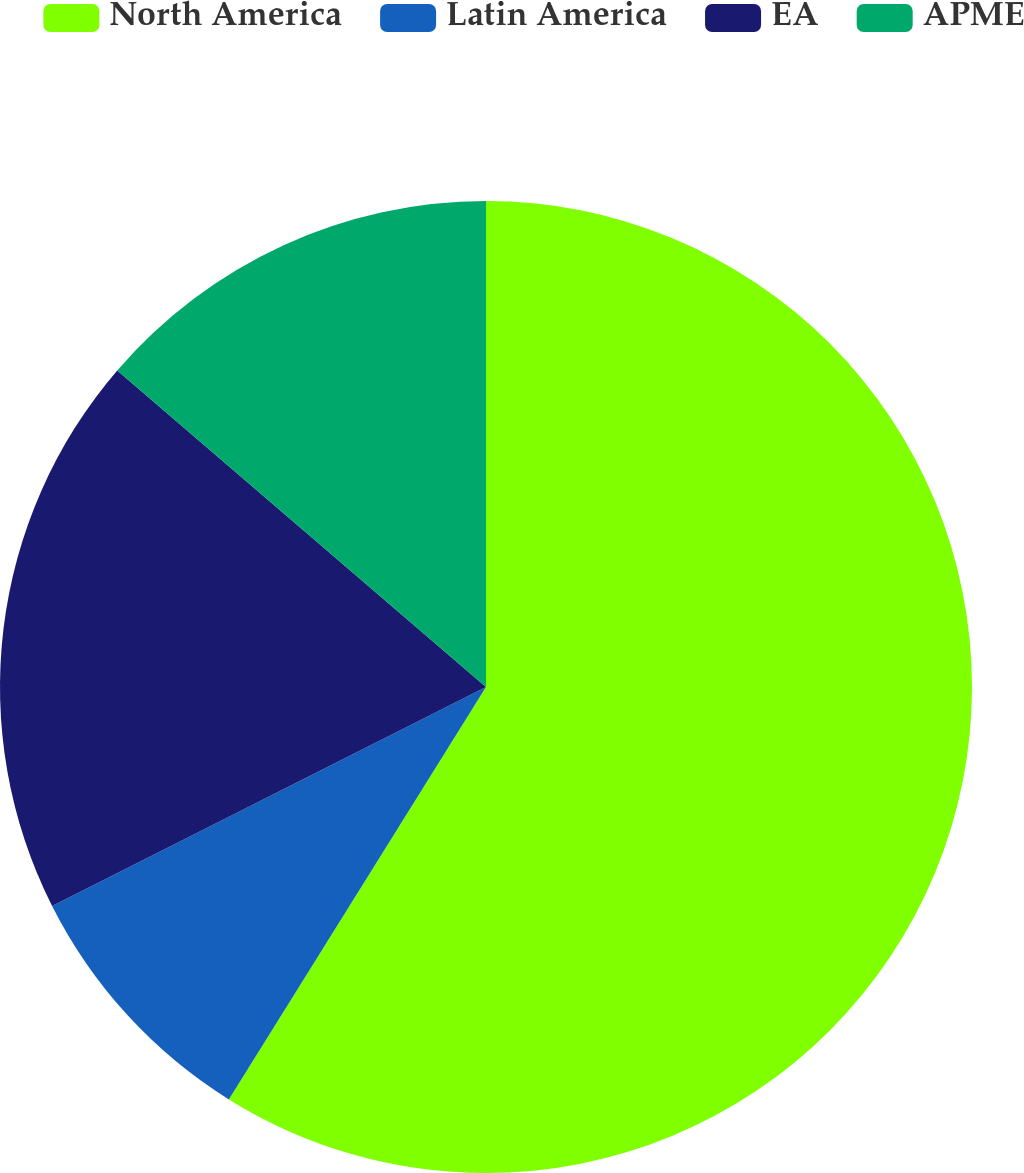<chart> <loc_0><loc_0><loc_500><loc_500><pie_chart><fcel>North America<fcel>Latin America<fcel>EA<fcel>APME<nl><fcel>58.88%<fcel>8.69%<fcel>18.73%<fcel>13.71%<nl></chart> 